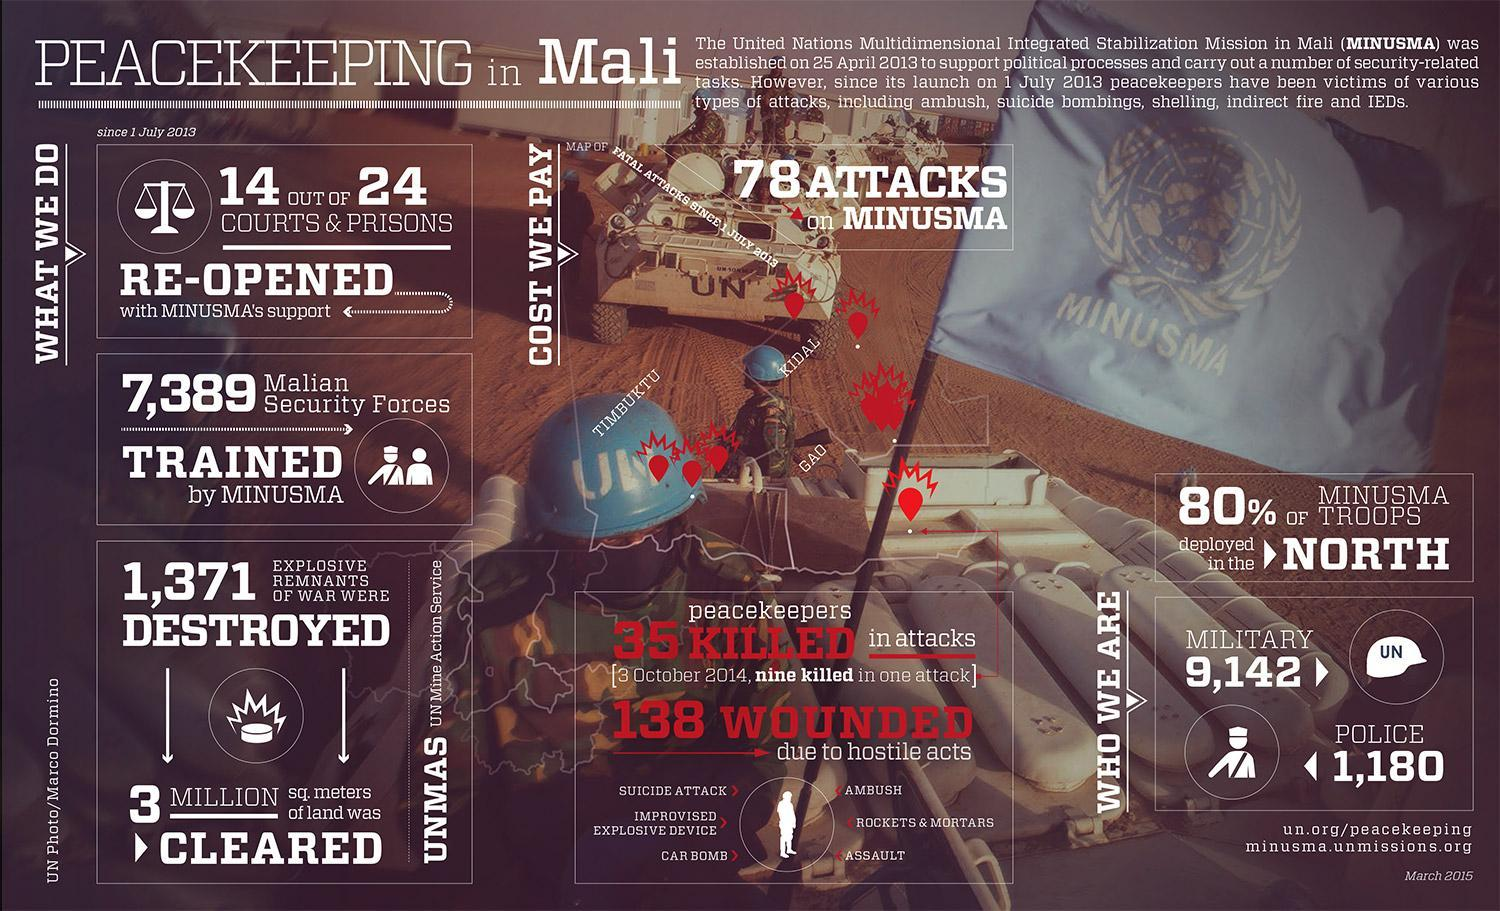How many attacks were targeted on MINUSMA since 1 July 2013?
Answer the question with a short phrase. 78 How many police personnels were deployed by the UN for MINUSMA? 1,180 How many military troops were deployed by the UN for MINUSMA? 9,142 How many UN peacekeepers were wounded due to hostile acts? 138 How many explosive remnants of war were destroyed by the UNMAS? 1,371 What percentage of MINUSMA troops were deployed in the North? 80% 